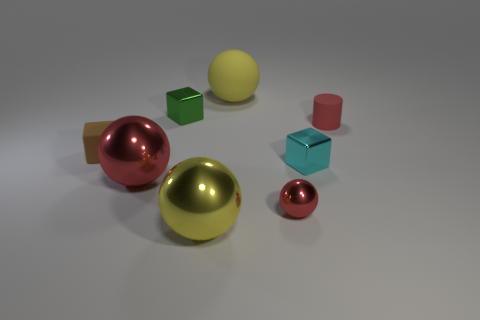How many small brown matte things are the same shape as the tiny green shiny object?
Ensure brevity in your answer.  1. There is a cylinder that is the same color as the small ball; what is it made of?
Keep it short and to the point. Rubber. How many purple rubber balls are there?
Provide a succinct answer. 0. There is a small brown thing; is its shape the same as the green metallic object that is on the right side of the brown matte cube?
Your answer should be compact. Yes. What number of objects are tiny yellow matte cylinders or red metal things on the left side of the large matte object?
Your answer should be compact. 1. There is a tiny green thing that is the same shape as the cyan shiny thing; what is its material?
Provide a short and direct response. Metal. Do the small matte thing right of the green metal thing and the tiny red metallic thing have the same shape?
Offer a terse response. No. Are there fewer balls that are left of the tiny brown matte thing than red things that are in front of the small cyan shiny block?
Ensure brevity in your answer.  Yes. How many other things are there of the same shape as the large rubber object?
Offer a very short reply. 3. How big is the red thing that is right of the cyan thing in front of the tiny red object that is behind the tiny cyan block?
Provide a short and direct response. Small. 